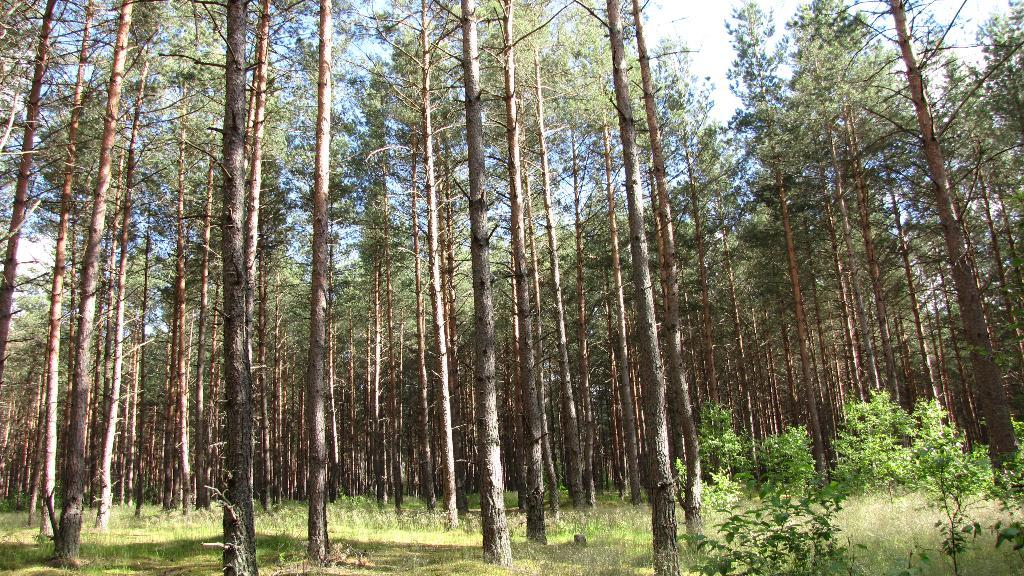What type of vegetation can be seen in the image? There is grass, plants, and trees in the image. What is visible in the background of the image? The sky is visible in the background of the image. What is the condition of the sky in the image? The sky is clear in the image. What type of appliance can be seen in the image? There is no appliance present in the image. What direction is the way leading in the image? There is no way or path visible in the image. 